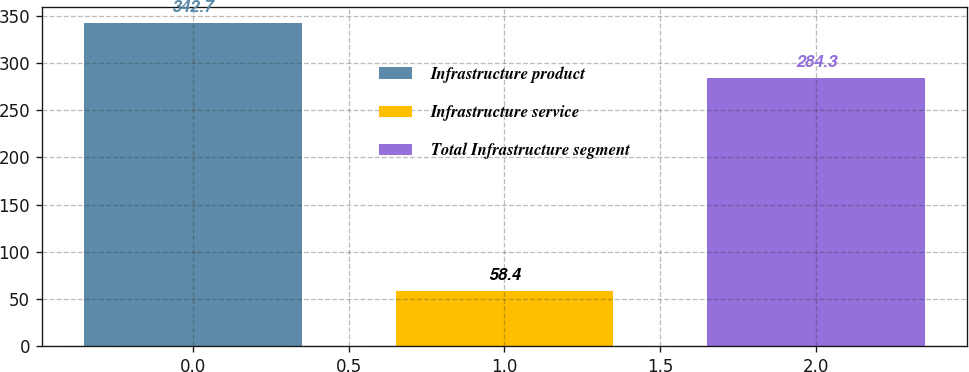Convert chart. <chart><loc_0><loc_0><loc_500><loc_500><bar_chart><fcel>Infrastructure product<fcel>Infrastructure service<fcel>Total Infrastructure segment<nl><fcel>342.7<fcel>58.4<fcel>284.3<nl></chart> 